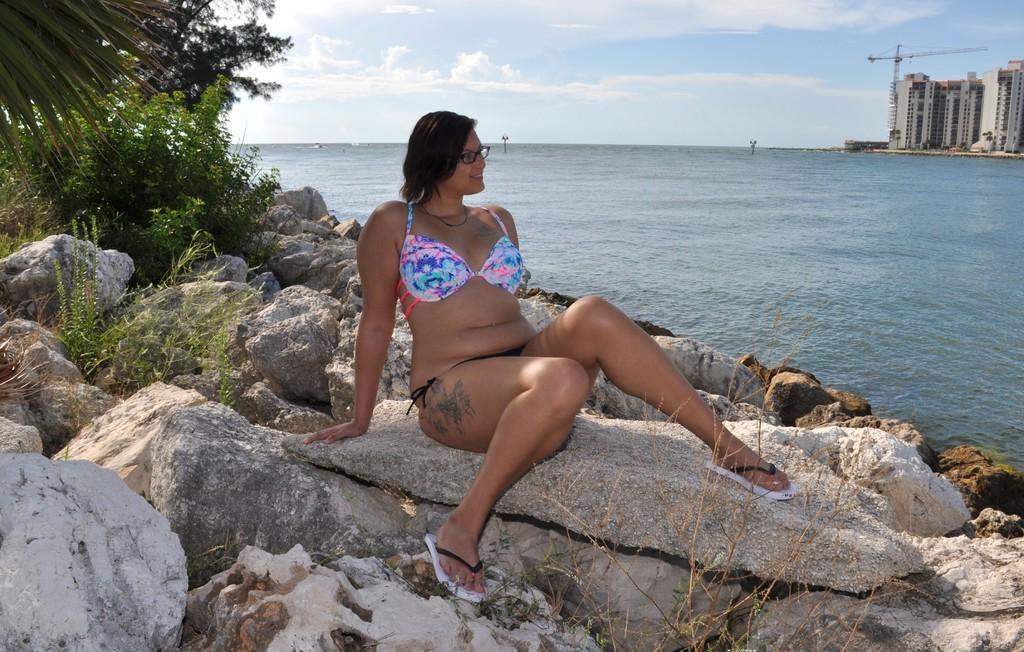In one or two sentences, can you explain what this image depicts? There is a lady wearing specs is sitting on a rock. On the left side there are rocks, plants and trees. On the right side there is water and buildings. In the background there is sky. 